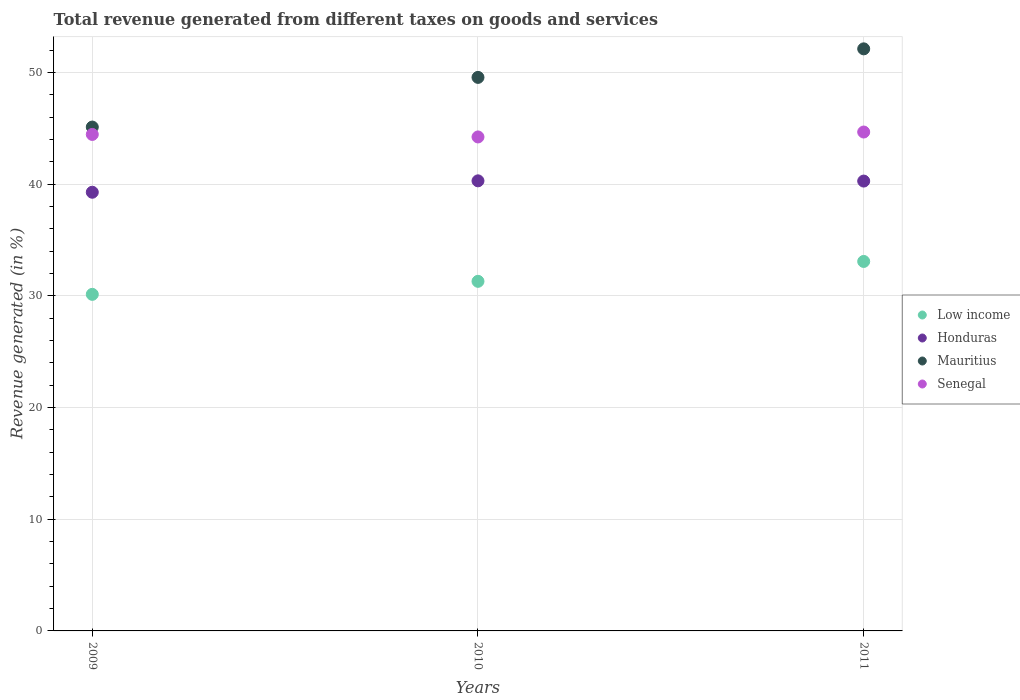How many different coloured dotlines are there?
Offer a terse response. 4. What is the total revenue generated in Honduras in 2011?
Ensure brevity in your answer.  40.27. Across all years, what is the maximum total revenue generated in Honduras?
Provide a short and direct response. 40.29. Across all years, what is the minimum total revenue generated in Honduras?
Give a very brief answer. 39.27. What is the total total revenue generated in Mauritius in the graph?
Ensure brevity in your answer.  146.77. What is the difference between the total revenue generated in Senegal in 2009 and that in 2010?
Your response must be concise. 0.23. What is the difference between the total revenue generated in Mauritius in 2011 and the total revenue generated in Honduras in 2010?
Your answer should be very brief. 11.82. What is the average total revenue generated in Senegal per year?
Make the answer very short. 44.45. In the year 2009, what is the difference between the total revenue generated in Senegal and total revenue generated in Honduras?
Your answer should be very brief. 5.18. In how many years, is the total revenue generated in Low income greater than 16 %?
Provide a short and direct response. 3. What is the ratio of the total revenue generated in Mauritius in 2009 to that in 2010?
Your answer should be compact. 0.91. Is the total revenue generated in Honduras in 2009 less than that in 2011?
Your answer should be compact. Yes. What is the difference between the highest and the second highest total revenue generated in Low income?
Provide a short and direct response. 1.78. What is the difference between the highest and the lowest total revenue generated in Low income?
Keep it short and to the point. 2.95. Is it the case that in every year, the sum of the total revenue generated in Senegal and total revenue generated in Honduras  is greater than the total revenue generated in Mauritius?
Your answer should be compact. Yes. Does the total revenue generated in Mauritius monotonically increase over the years?
Provide a short and direct response. Yes. Is the total revenue generated in Low income strictly greater than the total revenue generated in Senegal over the years?
Make the answer very short. No. Is the total revenue generated in Mauritius strictly less than the total revenue generated in Honduras over the years?
Provide a succinct answer. No. How many dotlines are there?
Offer a very short reply. 4. Does the graph contain any zero values?
Provide a short and direct response. No. What is the title of the graph?
Your answer should be very brief. Total revenue generated from different taxes on goods and services. What is the label or title of the X-axis?
Your answer should be compact. Years. What is the label or title of the Y-axis?
Make the answer very short. Revenue generated (in %). What is the Revenue generated (in %) in Low income in 2009?
Offer a terse response. 30.13. What is the Revenue generated (in %) in Honduras in 2009?
Give a very brief answer. 39.27. What is the Revenue generated (in %) in Mauritius in 2009?
Ensure brevity in your answer.  45.11. What is the Revenue generated (in %) of Senegal in 2009?
Your answer should be very brief. 44.45. What is the Revenue generated (in %) in Low income in 2010?
Provide a succinct answer. 31.3. What is the Revenue generated (in %) of Honduras in 2010?
Offer a very short reply. 40.29. What is the Revenue generated (in %) in Mauritius in 2010?
Give a very brief answer. 49.56. What is the Revenue generated (in %) in Senegal in 2010?
Make the answer very short. 44.22. What is the Revenue generated (in %) of Low income in 2011?
Your response must be concise. 33.08. What is the Revenue generated (in %) in Honduras in 2011?
Your response must be concise. 40.27. What is the Revenue generated (in %) of Mauritius in 2011?
Offer a very short reply. 52.11. What is the Revenue generated (in %) of Senegal in 2011?
Ensure brevity in your answer.  44.66. Across all years, what is the maximum Revenue generated (in %) of Low income?
Provide a short and direct response. 33.08. Across all years, what is the maximum Revenue generated (in %) of Honduras?
Ensure brevity in your answer.  40.29. Across all years, what is the maximum Revenue generated (in %) in Mauritius?
Offer a terse response. 52.11. Across all years, what is the maximum Revenue generated (in %) of Senegal?
Ensure brevity in your answer.  44.66. Across all years, what is the minimum Revenue generated (in %) of Low income?
Make the answer very short. 30.13. Across all years, what is the minimum Revenue generated (in %) of Honduras?
Offer a terse response. 39.27. Across all years, what is the minimum Revenue generated (in %) in Mauritius?
Ensure brevity in your answer.  45.11. Across all years, what is the minimum Revenue generated (in %) in Senegal?
Make the answer very short. 44.22. What is the total Revenue generated (in %) of Low income in the graph?
Provide a short and direct response. 94.51. What is the total Revenue generated (in %) in Honduras in the graph?
Provide a short and direct response. 119.84. What is the total Revenue generated (in %) of Mauritius in the graph?
Offer a very short reply. 146.77. What is the total Revenue generated (in %) in Senegal in the graph?
Provide a succinct answer. 133.34. What is the difference between the Revenue generated (in %) of Low income in 2009 and that in 2010?
Make the answer very short. -1.17. What is the difference between the Revenue generated (in %) of Honduras in 2009 and that in 2010?
Offer a terse response. -1.02. What is the difference between the Revenue generated (in %) of Mauritius in 2009 and that in 2010?
Offer a terse response. -4.45. What is the difference between the Revenue generated (in %) in Senegal in 2009 and that in 2010?
Give a very brief answer. 0.23. What is the difference between the Revenue generated (in %) of Low income in 2009 and that in 2011?
Give a very brief answer. -2.95. What is the difference between the Revenue generated (in %) of Honduras in 2009 and that in 2011?
Your answer should be compact. -1. What is the difference between the Revenue generated (in %) of Mauritius in 2009 and that in 2011?
Your answer should be very brief. -7. What is the difference between the Revenue generated (in %) in Senegal in 2009 and that in 2011?
Provide a succinct answer. -0.22. What is the difference between the Revenue generated (in %) in Low income in 2010 and that in 2011?
Provide a succinct answer. -1.78. What is the difference between the Revenue generated (in %) of Honduras in 2010 and that in 2011?
Offer a terse response. 0.02. What is the difference between the Revenue generated (in %) of Mauritius in 2010 and that in 2011?
Keep it short and to the point. -2.56. What is the difference between the Revenue generated (in %) of Senegal in 2010 and that in 2011?
Offer a very short reply. -0.44. What is the difference between the Revenue generated (in %) of Low income in 2009 and the Revenue generated (in %) of Honduras in 2010?
Give a very brief answer. -10.16. What is the difference between the Revenue generated (in %) of Low income in 2009 and the Revenue generated (in %) of Mauritius in 2010?
Offer a terse response. -19.42. What is the difference between the Revenue generated (in %) in Low income in 2009 and the Revenue generated (in %) in Senegal in 2010?
Make the answer very short. -14.09. What is the difference between the Revenue generated (in %) in Honduras in 2009 and the Revenue generated (in %) in Mauritius in 2010?
Ensure brevity in your answer.  -10.28. What is the difference between the Revenue generated (in %) in Honduras in 2009 and the Revenue generated (in %) in Senegal in 2010?
Give a very brief answer. -4.95. What is the difference between the Revenue generated (in %) of Mauritius in 2009 and the Revenue generated (in %) of Senegal in 2010?
Offer a very short reply. 0.89. What is the difference between the Revenue generated (in %) of Low income in 2009 and the Revenue generated (in %) of Honduras in 2011?
Provide a short and direct response. -10.14. What is the difference between the Revenue generated (in %) of Low income in 2009 and the Revenue generated (in %) of Mauritius in 2011?
Keep it short and to the point. -21.98. What is the difference between the Revenue generated (in %) of Low income in 2009 and the Revenue generated (in %) of Senegal in 2011?
Provide a succinct answer. -14.53. What is the difference between the Revenue generated (in %) of Honduras in 2009 and the Revenue generated (in %) of Mauritius in 2011?
Provide a short and direct response. -12.84. What is the difference between the Revenue generated (in %) in Honduras in 2009 and the Revenue generated (in %) in Senegal in 2011?
Your answer should be compact. -5.39. What is the difference between the Revenue generated (in %) in Mauritius in 2009 and the Revenue generated (in %) in Senegal in 2011?
Ensure brevity in your answer.  0.44. What is the difference between the Revenue generated (in %) in Low income in 2010 and the Revenue generated (in %) in Honduras in 2011?
Your answer should be compact. -8.98. What is the difference between the Revenue generated (in %) in Low income in 2010 and the Revenue generated (in %) in Mauritius in 2011?
Keep it short and to the point. -20.81. What is the difference between the Revenue generated (in %) of Low income in 2010 and the Revenue generated (in %) of Senegal in 2011?
Your answer should be very brief. -13.37. What is the difference between the Revenue generated (in %) of Honduras in 2010 and the Revenue generated (in %) of Mauritius in 2011?
Offer a terse response. -11.82. What is the difference between the Revenue generated (in %) in Honduras in 2010 and the Revenue generated (in %) in Senegal in 2011?
Ensure brevity in your answer.  -4.37. What is the difference between the Revenue generated (in %) in Mauritius in 2010 and the Revenue generated (in %) in Senegal in 2011?
Offer a very short reply. 4.89. What is the average Revenue generated (in %) of Low income per year?
Give a very brief answer. 31.5. What is the average Revenue generated (in %) in Honduras per year?
Keep it short and to the point. 39.95. What is the average Revenue generated (in %) in Mauritius per year?
Provide a short and direct response. 48.92. What is the average Revenue generated (in %) in Senegal per year?
Ensure brevity in your answer.  44.45. In the year 2009, what is the difference between the Revenue generated (in %) in Low income and Revenue generated (in %) in Honduras?
Give a very brief answer. -9.14. In the year 2009, what is the difference between the Revenue generated (in %) in Low income and Revenue generated (in %) in Mauritius?
Keep it short and to the point. -14.98. In the year 2009, what is the difference between the Revenue generated (in %) of Low income and Revenue generated (in %) of Senegal?
Offer a very short reply. -14.32. In the year 2009, what is the difference between the Revenue generated (in %) of Honduras and Revenue generated (in %) of Mauritius?
Offer a terse response. -5.84. In the year 2009, what is the difference between the Revenue generated (in %) of Honduras and Revenue generated (in %) of Senegal?
Your answer should be compact. -5.18. In the year 2009, what is the difference between the Revenue generated (in %) of Mauritius and Revenue generated (in %) of Senegal?
Provide a short and direct response. 0.66. In the year 2010, what is the difference between the Revenue generated (in %) in Low income and Revenue generated (in %) in Honduras?
Offer a terse response. -9. In the year 2010, what is the difference between the Revenue generated (in %) in Low income and Revenue generated (in %) in Mauritius?
Make the answer very short. -18.26. In the year 2010, what is the difference between the Revenue generated (in %) in Low income and Revenue generated (in %) in Senegal?
Offer a very short reply. -12.93. In the year 2010, what is the difference between the Revenue generated (in %) in Honduras and Revenue generated (in %) in Mauritius?
Your response must be concise. -9.26. In the year 2010, what is the difference between the Revenue generated (in %) in Honduras and Revenue generated (in %) in Senegal?
Your answer should be compact. -3.93. In the year 2010, what is the difference between the Revenue generated (in %) of Mauritius and Revenue generated (in %) of Senegal?
Provide a short and direct response. 5.33. In the year 2011, what is the difference between the Revenue generated (in %) of Low income and Revenue generated (in %) of Honduras?
Offer a very short reply. -7.2. In the year 2011, what is the difference between the Revenue generated (in %) in Low income and Revenue generated (in %) in Mauritius?
Your answer should be compact. -19.03. In the year 2011, what is the difference between the Revenue generated (in %) of Low income and Revenue generated (in %) of Senegal?
Provide a short and direct response. -11.59. In the year 2011, what is the difference between the Revenue generated (in %) in Honduras and Revenue generated (in %) in Mauritius?
Keep it short and to the point. -11.84. In the year 2011, what is the difference between the Revenue generated (in %) of Honduras and Revenue generated (in %) of Senegal?
Make the answer very short. -4.39. In the year 2011, what is the difference between the Revenue generated (in %) of Mauritius and Revenue generated (in %) of Senegal?
Your answer should be compact. 7.45. What is the ratio of the Revenue generated (in %) of Low income in 2009 to that in 2010?
Ensure brevity in your answer.  0.96. What is the ratio of the Revenue generated (in %) in Honduras in 2009 to that in 2010?
Ensure brevity in your answer.  0.97. What is the ratio of the Revenue generated (in %) of Mauritius in 2009 to that in 2010?
Your answer should be compact. 0.91. What is the ratio of the Revenue generated (in %) of Senegal in 2009 to that in 2010?
Offer a terse response. 1.01. What is the ratio of the Revenue generated (in %) in Low income in 2009 to that in 2011?
Make the answer very short. 0.91. What is the ratio of the Revenue generated (in %) of Honduras in 2009 to that in 2011?
Your answer should be compact. 0.98. What is the ratio of the Revenue generated (in %) in Mauritius in 2009 to that in 2011?
Keep it short and to the point. 0.87. What is the ratio of the Revenue generated (in %) of Low income in 2010 to that in 2011?
Your response must be concise. 0.95. What is the ratio of the Revenue generated (in %) in Honduras in 2010 to that in 2011?
Offer a very short reply. 1. What is the ratio of the Revenue generated (in %) in Mauritius in 2010 to that in 2011?
Offer a terse response. 0.95. What is the difference between the highest and the second highest Revenue generated (in %) of Low income?
Keep it short and to the point. 1.78. What is the difference between the highest and the second highest Revenue generated (in %) in Honduras?
Make the answer very short. 0.02. What is the difference between the highest and the second highest Revenue generated (in %) of Mauritius?
Ensure brevity in your answer.  2.56. What is the difference between the highest and the second highest Revenue generated (in %) of Senegal?
Your answer should be compact. 0.22. What is the difference between the highest and the lowest Revenue generated (in %) of Low income?
Provide a short and direct response. 2.95. What is the difference between the highest and the lowest Revenue generated (in %) of Honduras?
Your answer should be compact. 1.02. What is the difference between the highest and the lowest Revenue generated (in %) of Mauritius?
Provide a succinct answer. 7. What is the difference between the highest and the lowest Revenue generated (in %) of Senegal?
Ensure brevity in your answer.  0.44. 